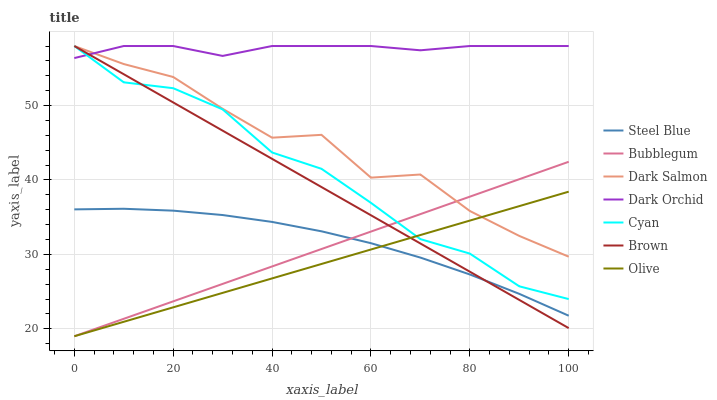Does Olive have the minimum area under the curve?
Answer yes or no. Yes. Does Dark Orchid have the maximum area under the curve?
Answer yes or no. Yes. Does Steel Blue have the minimum area under the curve?
Answer yes or no. No. Does Steel Blue have the maximum area under the curve?
Answer yes or no. No. Is Olive the smoothest?
Answer yes or no. Yes. Is Dark Salmon the roughest?
Answer yes or no. Yes. Is Steel Blue the smoothest?
Answer yes or no. No. Is Steel Blue the roughest?
Answer yes or no. No. Does Bubblegum have the lowest value?
Answer yes or no. Yes. Does Steel Blue have the lowest value?
Answer yes or no. No. Does Cyan have the highest value?
Answer yes or no. Yes. Does Steel Blue have the highest value?
Answer yes or no. No. Is Steel Blue less than Dark Salmon?
Answer yes or no. Yes. Is Dark Orchid greater than Steel Blue?
Answer yes or no. Yes. Does Olive intersect Cyan?
Answer yes or no. Yes. Is Olive less than Cyan?
Answer yes or no. No. Is Olive greater than Cyan?
Answer yes or no. No. Does Steel Blue intersect Dark Salmon?
Answer yes or no. No. 